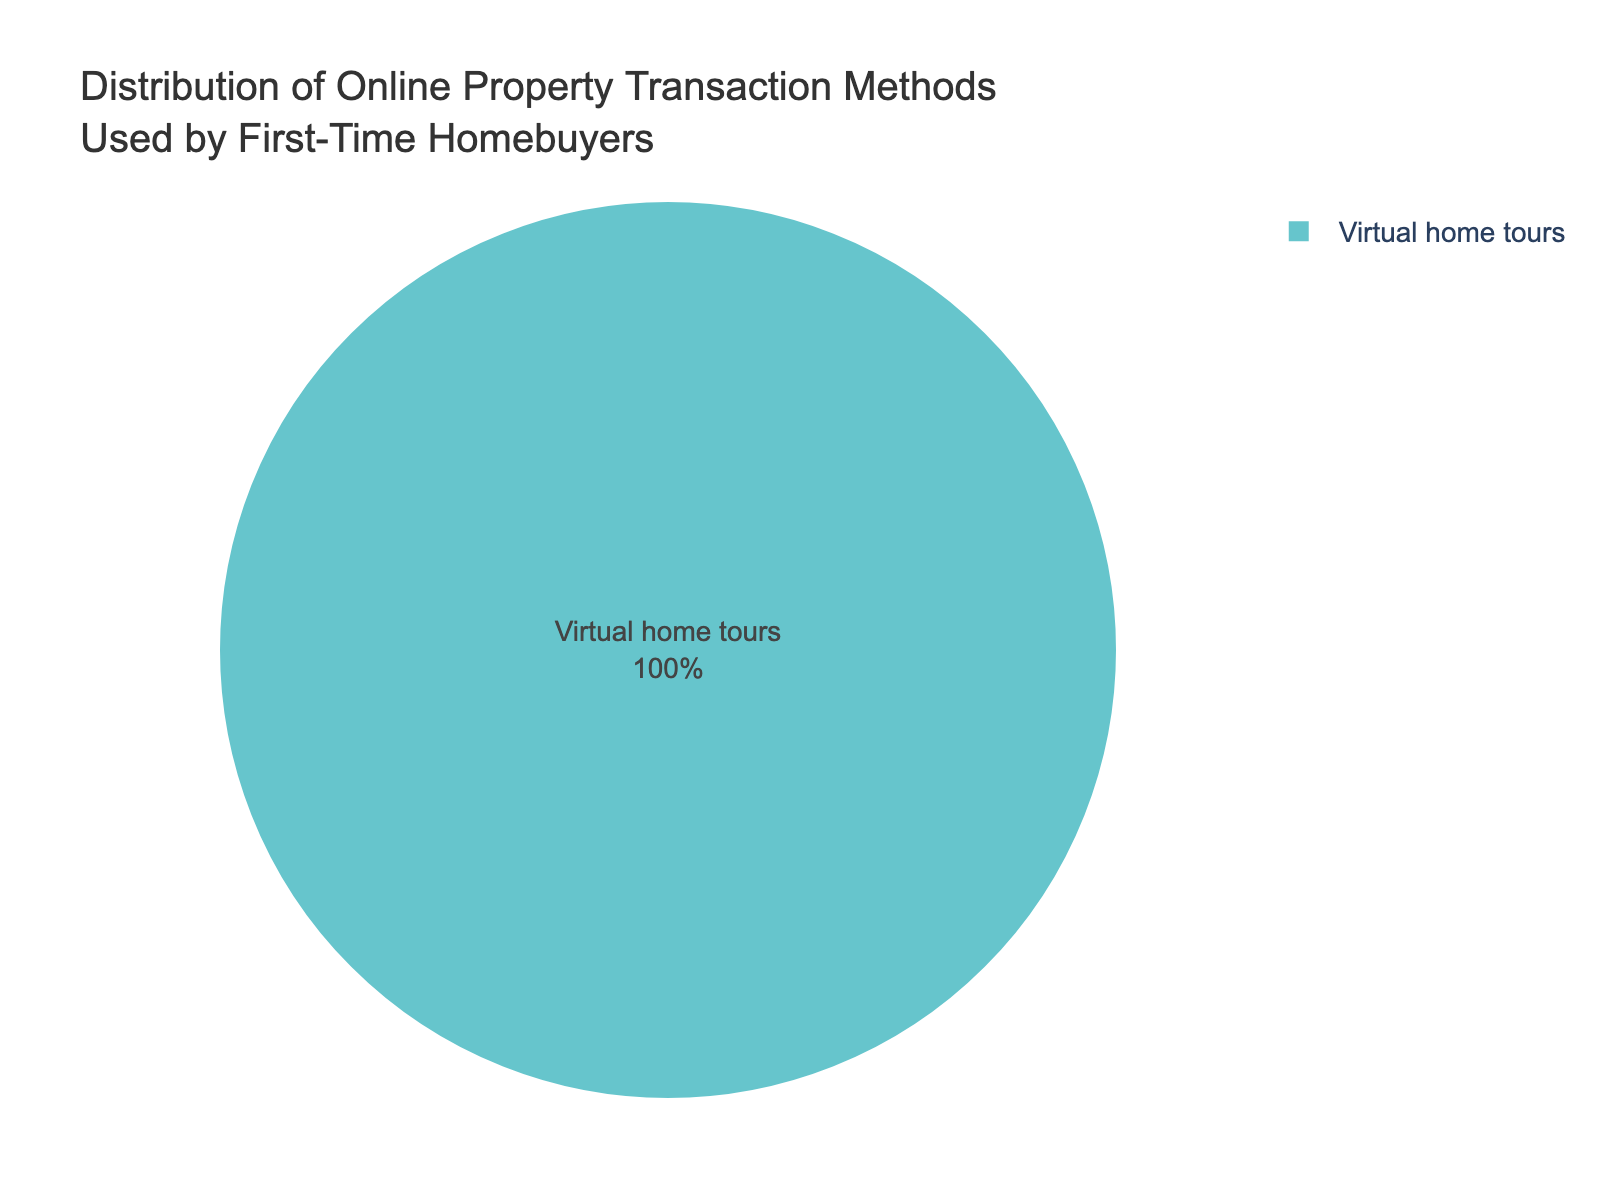What percentage of first-time homebuyers used virtual home tours for online property transactions? The pie chart shows that 10% of first-time homebuyers used virtual home tours.
Answer: 10% Is virtual home tour the only method shown in the pie chart? The pie chart only displays the percentage for virtual home tours, hence it appears to be the only method shown.
Answer: Yes What method is represented by the pie slice that makes up 10% of the chart? The label inside the pie slice indicates that the method accounting for 10% is virtual home tours.
Answer: Virtual home tours What is the color of the pie slice representing virtual home tours? The pie chart uses pastel colors, and the slice for virtual home tours is colored accordingly. Without specific color detail in the data, it's generally one of the lighter shades.
Answer: Light pastel color If the entire pie chart represents 100% of the first-time homebuyers, what proportion of this group used other methods apart from virtual home tours? Since virtual home tours make up 10% of the chart, the remaining 90% would represent other methods.
Answer: 90% What information is provided inside the pie slice for virtual home tours? The pie slice for virtual home tours has text inside it showing the printed percentage and label, indicating "10%" and "Virtual home tours".
Answer: 10% and Virtual home tours Based on the current dataset, can we determine how many other methods exist apart from virtual home tours? The pie chart only shows information about virtual home tours and does not give details about other methods or the number of such methods.
Answer: No What visual attribute helps to quickly identify the percentage associated with the virtual home tours method? The percentage is displayed inside the pie slice, providing clear and immediate visual information.
Answer: The percentage shown inside the slice 